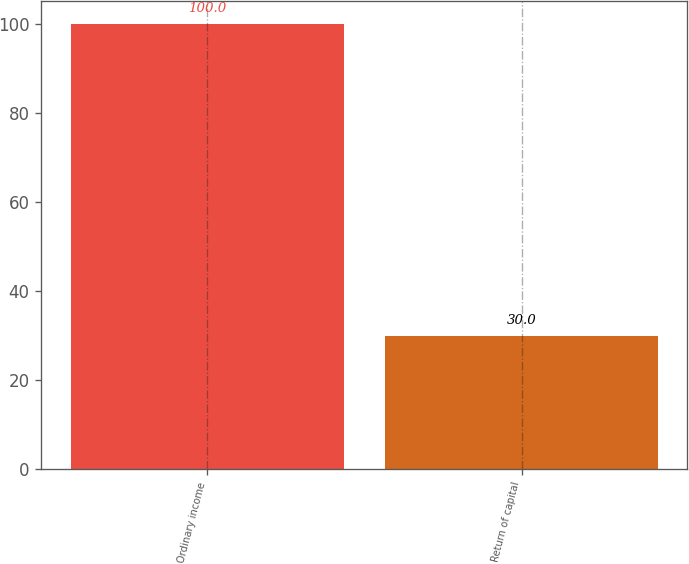Convert chart. <chart><loc_0><loc_0><loc_500><loc_500><bar_chart><fcel>Ordinary income<fcel>Return of capital<nl><fcel>100<fcel>30<nl></chart> 